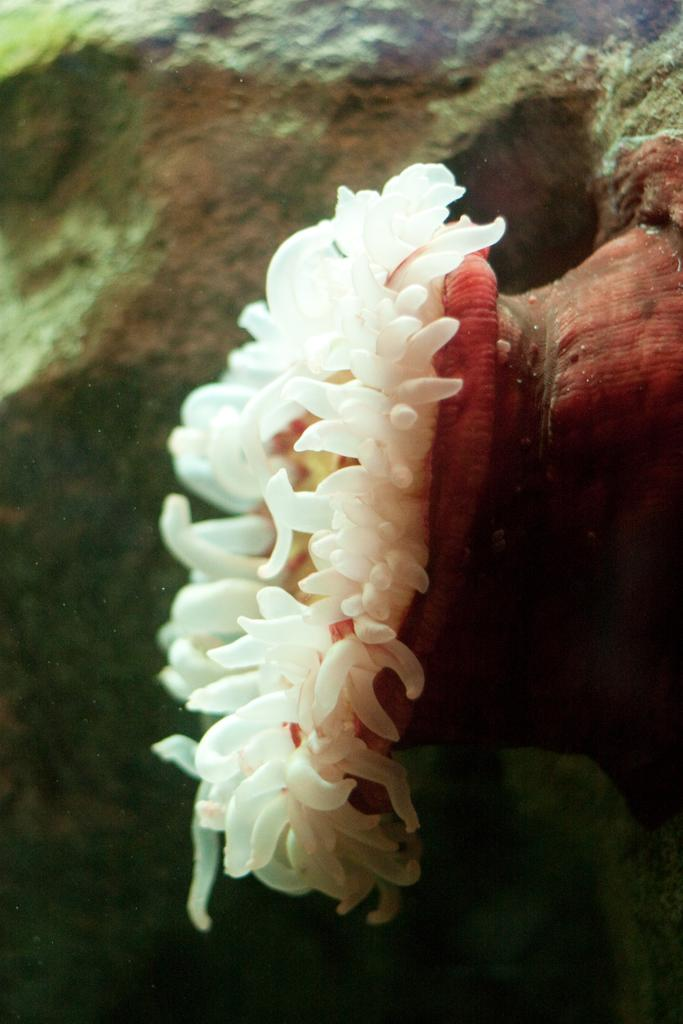What type of creature can be seen in the image? There is an underwater animal in the image. What type of downtown area can be seen in the image? There is no downtown area present in the image; it features an underwater animal. What type of berry is being held by the army in the image? There is no army or berry present in the image; it features an underwater animal. 